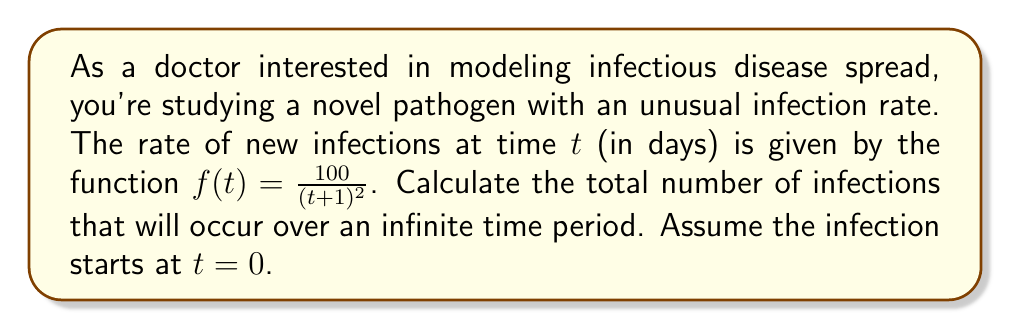Can you answer this question? To solve this problem, we need to evaluate an improper integral from 0 to infinity. The steps are as follows:

1) The total number of infections over time is given by the integral of the infection rate function:

   $$\int_0^\infty f(t) dt = \int_0^\infty \frac{100}{(t+1)^2} dt$$

2) This is an improper integral of the form $\int_a^\infty \frac{1}{(x+b)^n} dx$, which has a known solution.

3) Let's make a substitution: $u = t+1$, so $du = dt$. When $t=0$, $u=1$, and as $t \to \infty$, $u \to \infty$. The integral becomes:

   $$100 \int_1^\infty \frac{1}{u^2} du$$

4) The antiderivative of $\frac{1}{u^2}$ is $-\frac{1}{u}$, so we have:

   $$100 \left[-\frac{1}{u}\right]_1^\infty = 100 \left(\lim_{u \to \infty} -\frac{1}{u} - (-1)\right)$$

5) As $u$ approaches infinity, $\frac{1}{u}$ approaches 0, so:

   $$100 (0 - (-1)) = 100 (1) = 100$$

Therefore, the total number of infections over an infinite time period is 100.
Answer: 100 infections 